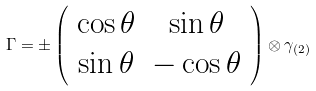<formula> <loc_0><loc_0><loc_500><loc_500>\Gamma = \pm \left ( \begin{array} { c c } { \cos \theta } & { \sin \theta } \\ { \sin \theta } & { - \cos \theta } \end{array} \right ) \otimes \gamma _ { ( 2 ) }</formula> 